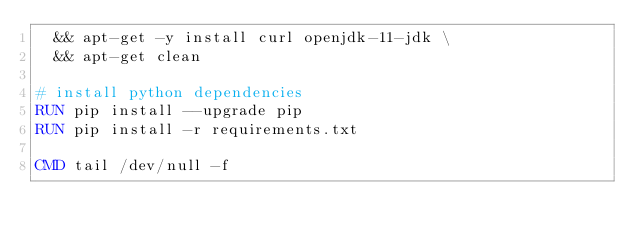Convert code to text. <code><loc_0><loc_0><loc_500><loc_500><_Dockerfile_>  && apt-get -y install curl openjdk-11-jdk \
  && apt-get clean

# install python dependencies
RUN pip install --upgrade pip
RUN pip install -r requirements.txt

CMD tail /dev/null -f
</code> 